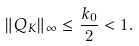<formula> <loc_0><loc_0><loc_500><loc_500>\| Q _ { K } \| _ { \infty } \leq \frac { k _ { 0 } } { 2 } < 1 .</formula> 